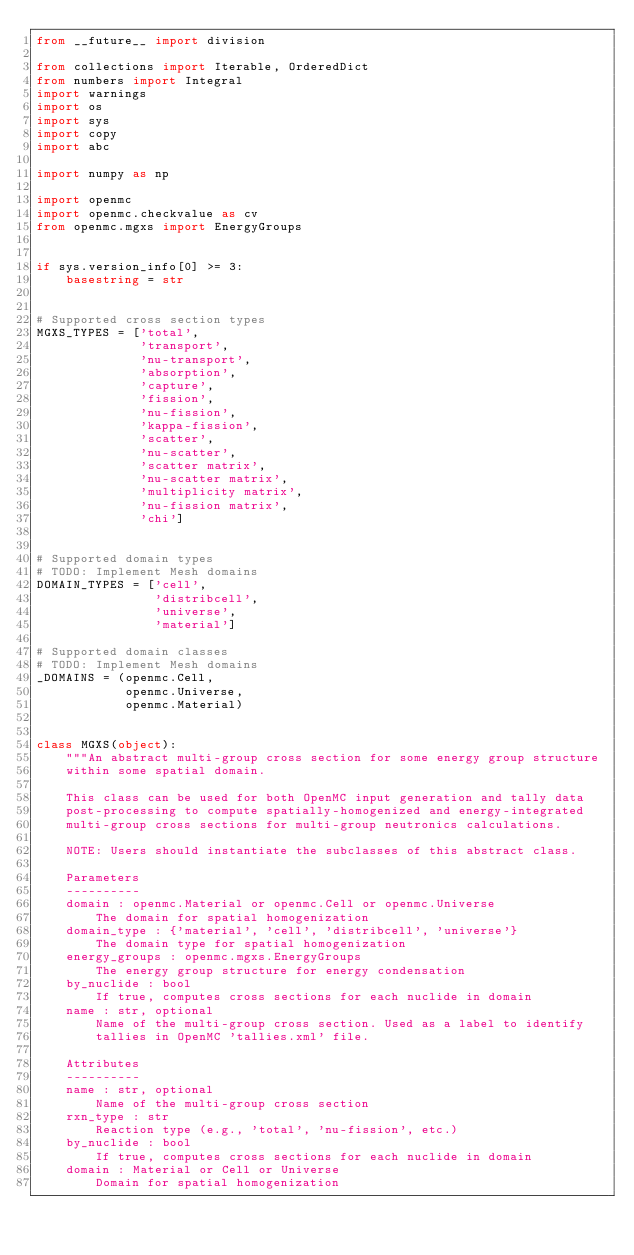<code> <loc_0><loc_0><loc_500><loc_500><_Python_>from __future__ import division

from collections import Iterable, OrderedDict
from numbers import Integral
import warnings
import os
import sys
import copy
import abc

import numpy as np

import openmc
import openmc.checkvalue as cv
from openmc.mgxs import EnergyGroups


if sys.version_info[0] >= 3:
    basestring = str


# Supported cross section types
MGXS_TYPES = ['total',
              'transport',
              'nu-transport',
              'absorption',
              'capture',
              'fission',
              'nu-fission',
              'kappa-fission',
              'scatter',
              'nu-scatter',
              'scatter matrix',
              'nu-scatter matrix',
              'multiplicity matrix',
              'nu-fission matrix',
              'chi']


# Supported domain types
# TODO: Implement Mesh domains
DOMAIN_TYPES = ['cell',
                'distribcell',
                'universe',
                'material']

# Supported domain classes
# TODO: Implement Mesh domains
_DOMAINS = (openmc.Cell,
            openmc.Universe,
            openmc.Material)


class MGXS(object):
    """An abstract multi-group cross section for some energy group structure
    within some spatial domain.

    This class can be used for both OpenMC input generation and tally data
    post-processing to compute spatially-homogenized and energy-integrated
    multi-group cross sections for multi-group neutronics calculations.

    NOTE: Users should instantiate the subclasses of this abstract class.

    Parameters
    ----------
    domain : openmc.Material or openmc.Cell or openmc.Universe
        The domain for spatial homogenization
    domain_type : {'material', 'cell', 'distribcell', 'universe'}
        The domain type for spatial homogenization
    energy_groups : openmc.mgxs.EnergyGroups
        The energy group structure for energy condensation
    by_nuclide : bool
        If true, computes cross sections for each nuclide in domain
    name : str, optional
        Name of the multi-group cross section. Used as a label to identify
        tallies in OpenMC 'tallies.xml' file.

    Attributes
    ----------
    name : str, optional
        Name of the multi-group cross section
    rxn_type : str
        Reaction type (e.g., 'total', 'nu-fission', etc.)
    by_nuclide : bool
        If true, computes cross sections for each nuclide in domain
    domain : Material or Cell or Universe
        Domain for spatial homogenization</code> 